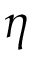<formula> <loc_0><loc_0><loc_500><loc_500>\eta</formula> 